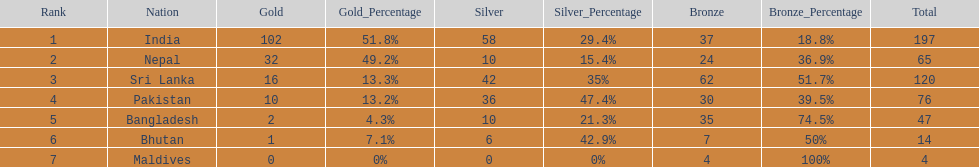What was the number of silver medals won by pakistan? 36. 